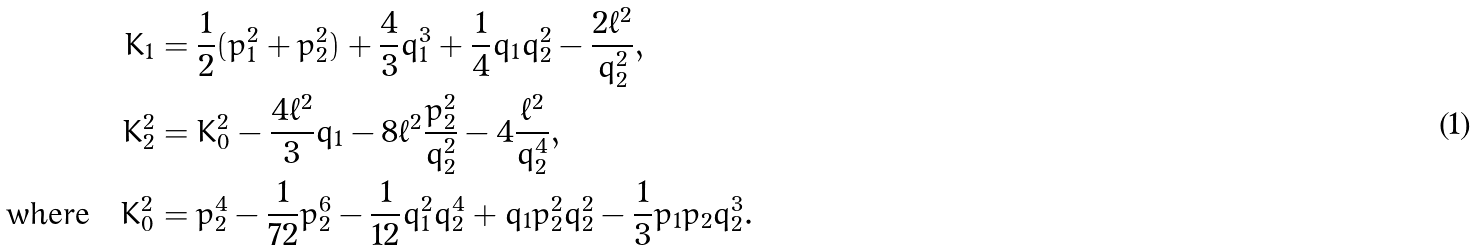Convert formula to latex. <formula><loc_0><loc_0><loc_500><loc_500>K _ { 1 } & = \frac { 1 } { 2 } ( p _ { 1 } ^ { 2 } + p _ { 2 } ^ { 2 } ) + \frac { 4 } { 3 } q _ { 1 } ^ { 3 } + \frac { 1 } { 4 } q _ { 1 } q _ { 2 } ^ { 2 } - \frac { 2 \ell ^ { 2 } } { q _ { 2 } ^ { 2 } } , \\ K _ { 2 } ^ { 2 } & = K _ { 0 } ^ { 2 } - \frac { 4 \ell ^ { 2 } } { 3 } q _ { 1 } - 8 \ell ^ { 2 } \frac { p _ { 2 } ^ { 2 } } { q _ { 2 } ^ { 2 } } - 4 \frac { \ell ^ { 2 } } { q _ { 2 } ^ { 4 } } , \\ \text {where} \quad K _ { 0 } ^ { 2 } & = p _ { 2 } ^ { 4 } - \frac { 1 } { 7 2 } p _ { 2 } ^ { 6 } - \frac { 1 } { 1 2 } q _ { 1 } ^ { 2 } q _ { 2 } ^ { 4 } + q _ { 1 } p _ { 2 } ^ { 2 } q _ { 2 } ^ { 2 } - \frac { 1 } { 3 } p _ { 1 } p _ { 2 } q _ { 2 } ^ { 3 } .</formula> 